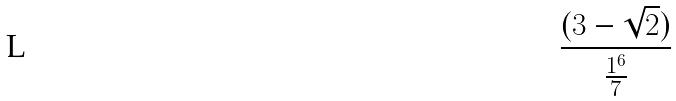<formula> <loc_0><loc_0><loc_500><loc_500>\frac { ( 3 - \sqrt { 2 } ) } { \frac { 1 ^ { 6 } } { 7 } }</formula> 